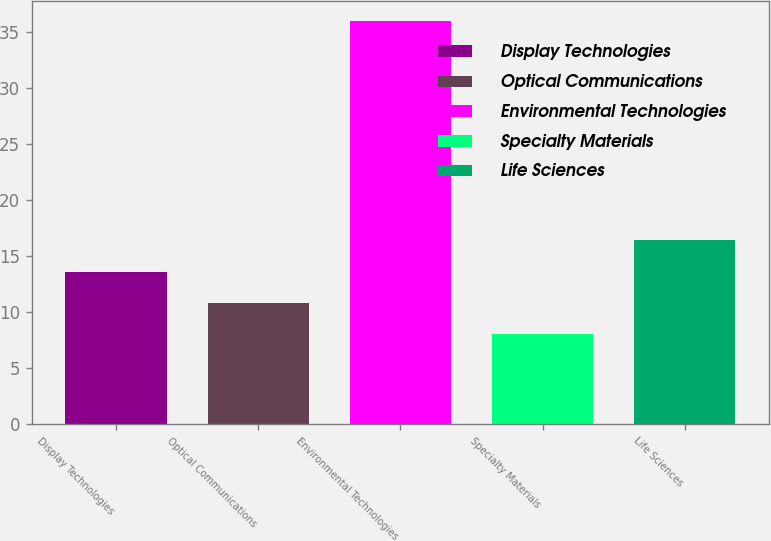Convert chart. <chart><loc_0><loc_0><loc_500><loc_500><bar_chart><fcel>Display Technologies<fcel>Optical Communications<fcel>Environmental Technologies<fcel>Specialty Materials<fcel>Life Sciences<nl><fcel>13.6<fcel>10.8<fcel>36<fcel>8<fcel>16.4<nl></chart> 